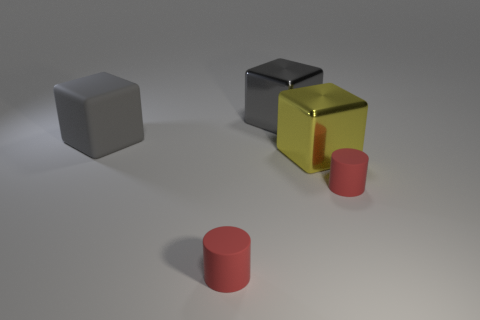Subtract all yellow cubes. How many cubes are left? 2 Subtract all yellow cubes. How many cubes are left? 2 Subtract 3 blocks. How many blocks are left? 0 Add 4 blue rubber spheres. How many objects exist? 9 Subtract all cylinders. How many objects are left? 3 Add 3 yellow things. How many yellow things are left? 4 Add 5 tiny matte things. How many tiny matte things exist? 7 Subtract 0 red balls. How many objects are left? 5 Subtract all brown blocks. Subtract all yellow cylinders. How many blocks are left? 3 Subtract all red cylinders. How many gray cubes are left? 2 